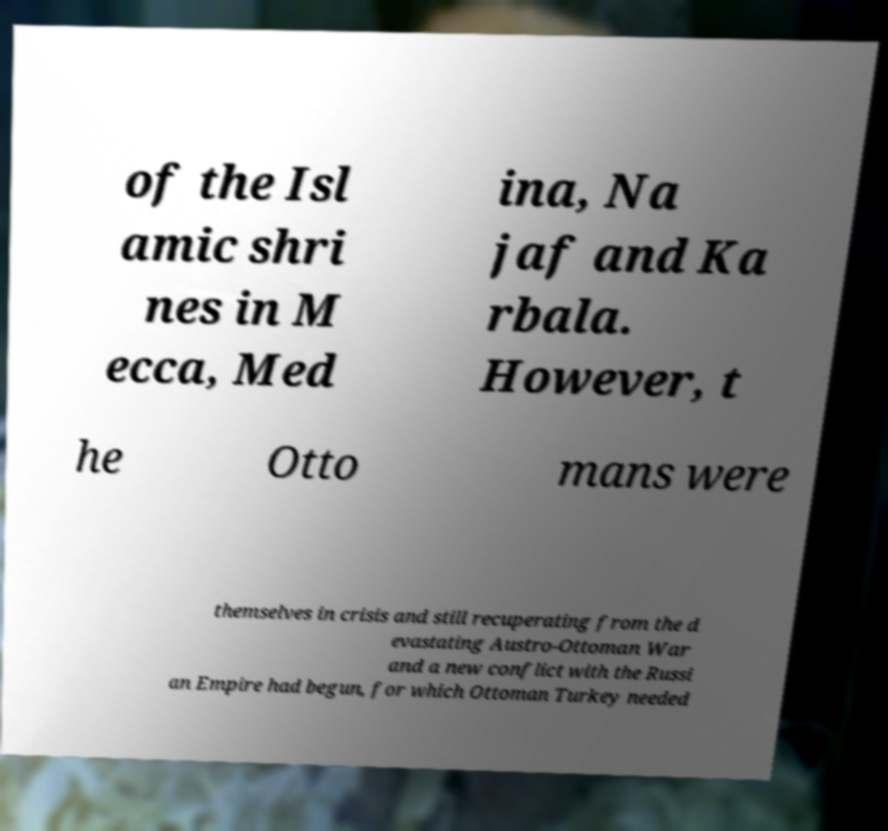Please identify and transcribe the text found in this image. of the Isl amic shri nes in M ecca, Med ina, Na jaf and Ka rbala. However, t he Otto mans were themselves in crisis and still recuperating from the d evastating Austro-Ottoman War and a new conflict with the Russi an Empire had begun, for which Ottoman Turkey needed 